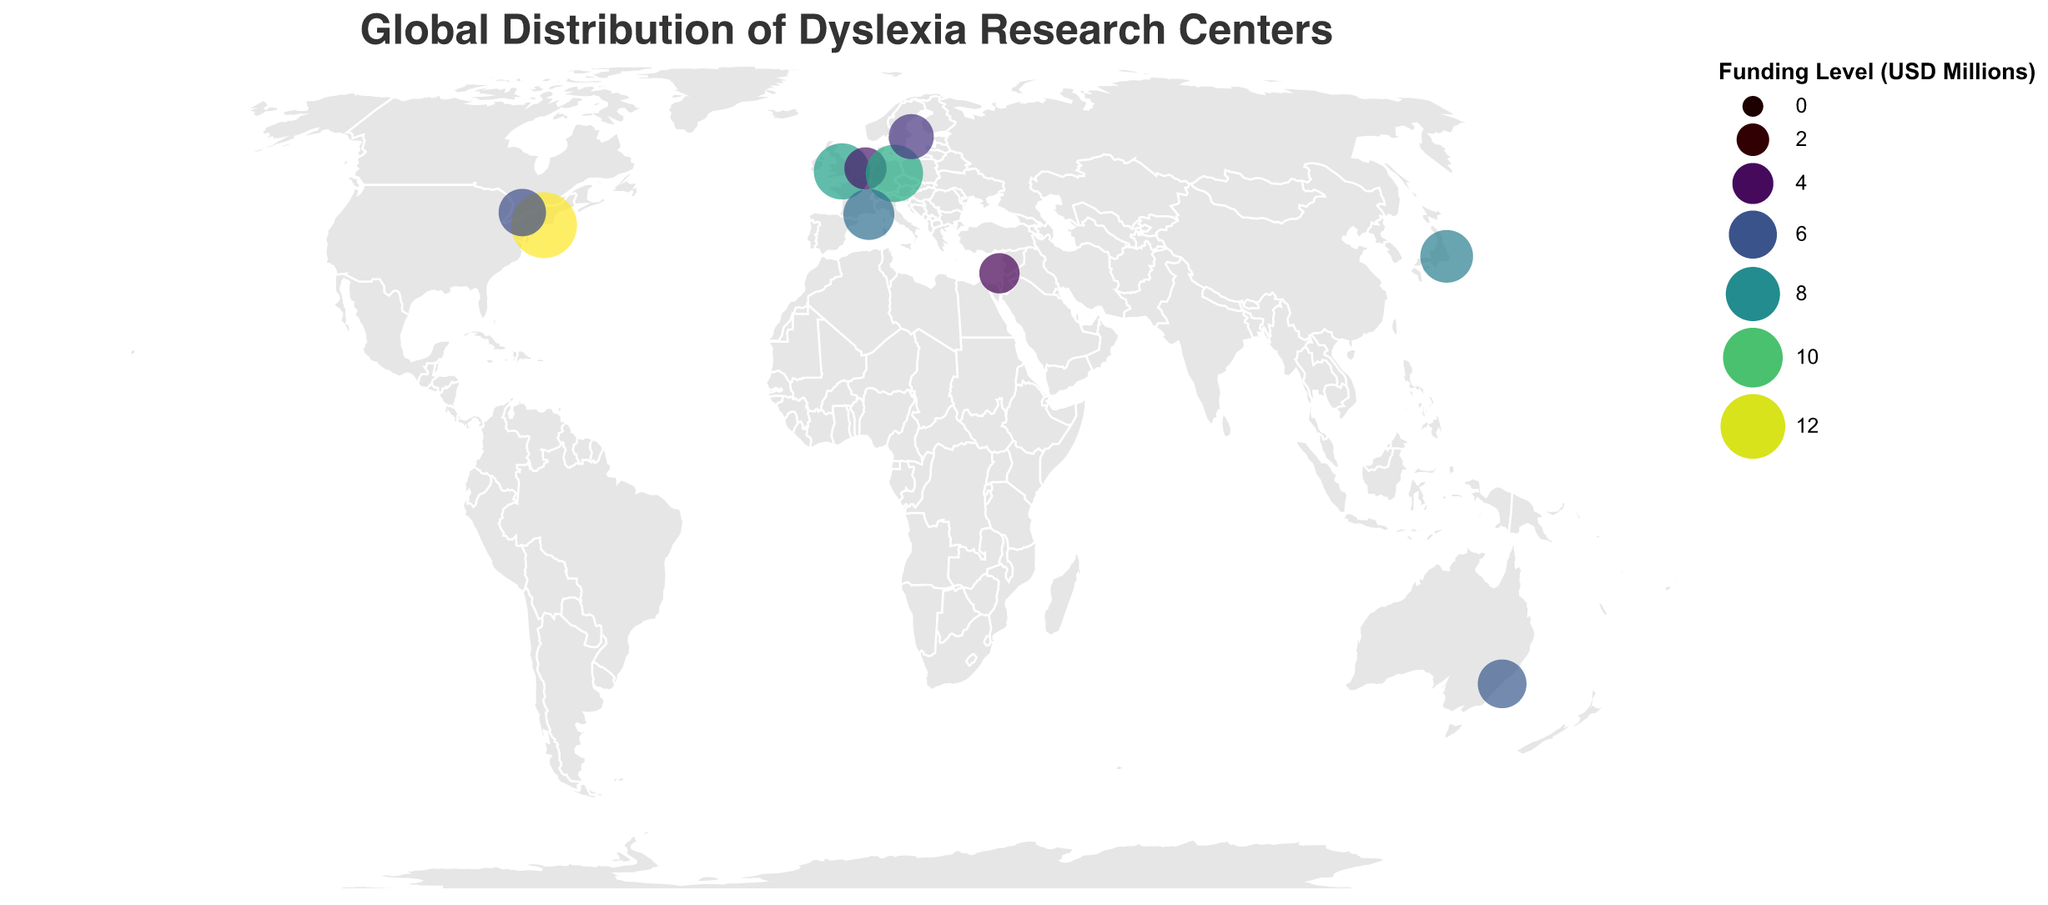What are the countries represented in the map? The countries represented are shown by the placement of circles on the map. Each circle has an associated latitude and longitude, and the legend indicates various research centers located globally.
Answer: USA, UK, Australia, Canada, Netherlands, Germany, Japan, France, Sweden, Israel Which research center has the highest funding level? By identifying the circle representing the highest funding level on the color scale legend, we can see that the Yale Center for Dyslexia & Creativity in the USA has the highest funding level at 12.5 million USD.
Answer: Yale Center for Dyslexia & Creativity Which two countries are closest to each other based on the research center locations? We need to look for countries with circles that are geographically close on the map. The research centers in the UK (Dyslexia Research Trust) and the Netherlands (Dyslexia International) appear to be closest to each other based on their near geographic coordinates in Europe.
Answer: UK and Netherlands What is the total funding level for research centers in Europe? The funding levels for Europe can be calculated by summing up the funding for centers in the UK (8.7 million USD), Netherlands (4.3 million USD), Germany (9.1 million USD), France (6.9 million USD), and Sweden (5.1 million USD). Total: 8.7 + 4.3 + 9.1 + 6.9 + 5.1 = 34.1 million USD.
Answer: 34.1 million USD Which research centers are in countries with a funding level greater than 7 million USD? By examining the circles associated with funding levels greater than 7 million USD, we identify research centers in the USA (12.5 million USD), UK (8.7 million USD), Germany (9.1 million USD), Japan (7.5 million USD), and France (6.9 million USD, which does not meet the criteria).
Answer: Yale Center for Dyslexia & Creativity, Dyslexia Research Trust, Max Planck Institute for Human Cognitive and Brain Sciences, University of Tokyo Research Center for Advanced Science and Technology How does the funding level for the Max Planck Institute in Germany compare with the Macquarie University Centre in Australia? The Max Planck Institute has a funding level of 9.1 million USD, while the Macquarie University Centre has a funding level of 6.2 million USD. Consequently, the Max Planck Institute has a higher funding level.
Answer: Max Planck Institute has higher funding Which continents have research centers represented on the map? By observing where the circles are placed, we can see research centers in North America, Europe, Asia, and Oceania (Australia).
Answer: North America, Europe, Asia, Oceania (Australia) What would be the average funding level for all the research centers shown on the map? To find the average funding level, sum up funding levels of all centers (12.5, 8.7, 6.2, 5.8, 4.3, 9.1, 7.5, 6.9, 5.1, 3.8) which totals 69.9 million USD. Dividing by the number of centers (10) gives 69.9 / 10 = 6.99 million USD.
Answer: 6.99 million USD 